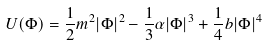<formula> <loc_0><loc_0><loc_500><loc_500>U ( \Phi ) = \frac { 1 } { 2 } m ^ { 2 } | \Phi | ^ { 2 } - \frac { 1 } { 3 } \alpha | \Phi | ^ { 3 } + \frac { 1 } { 4 } b | \Phi | ^ { 4 }</formula> 